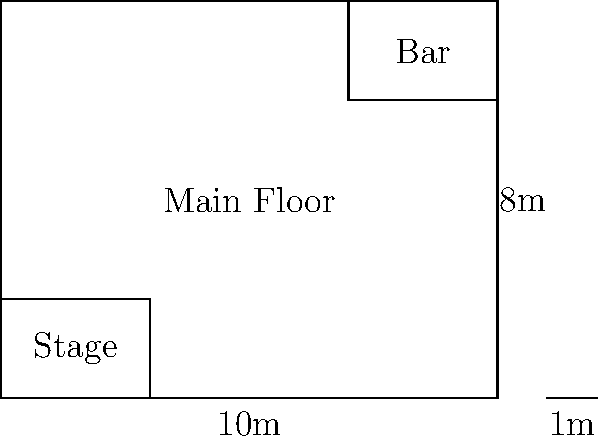Given the floor plan of a venue shown above, calculate the maximum occupancy based on local fire safety regulations that require 1.5 square meters per person. The main floor area excludes the stage and bar areas. Round down to the nearest whole number. To calculate the maximum occupancy, we need to follow these steps:

1. Calculate the total area of the venue:
   $$ \text{Total Area} = 10\text{m} \times 8\text{m} = 80\text{m}^2 $$

2. Calculate the area of the stage:
   $$ \text{Stage Area} = 3\text{m} \times 2\text{m} = 6\text{m}^2 $$

3. Calculate the area of the bar:
   $$ \text{Bar Area} = 3\text{m} \times 2\text{m} = 6\text{m}^2 $$

4. Calculate the main floor area by subtracting the stage and bar areas:
   $$ \text{Main Floor Area} = 80\text{m}^2 - 6\text{m}^2 - 6\text{m}^2 = 68\text{m}^2 $$

5. Calculate the maximum occupancy using the fire safety regulation:
   $$ \text{Maximum Occupancy} = \frac{\text{Main Floor Area}}{\text{Area per person}} = \frac{68\text{m}^2}{1.5\text{m}^2/\text{person}} = 45.33 \text{ people} $$

6. Round down to the nearest whole number:
   $$ \text{Maximum Occupancy} = 45 \text{ people} $$
Answer: 45 people 